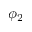Convert formula to latex. <formula><loc_0><loc_0><loc_500><loc_500>\phi _ { 2 }</formula> 